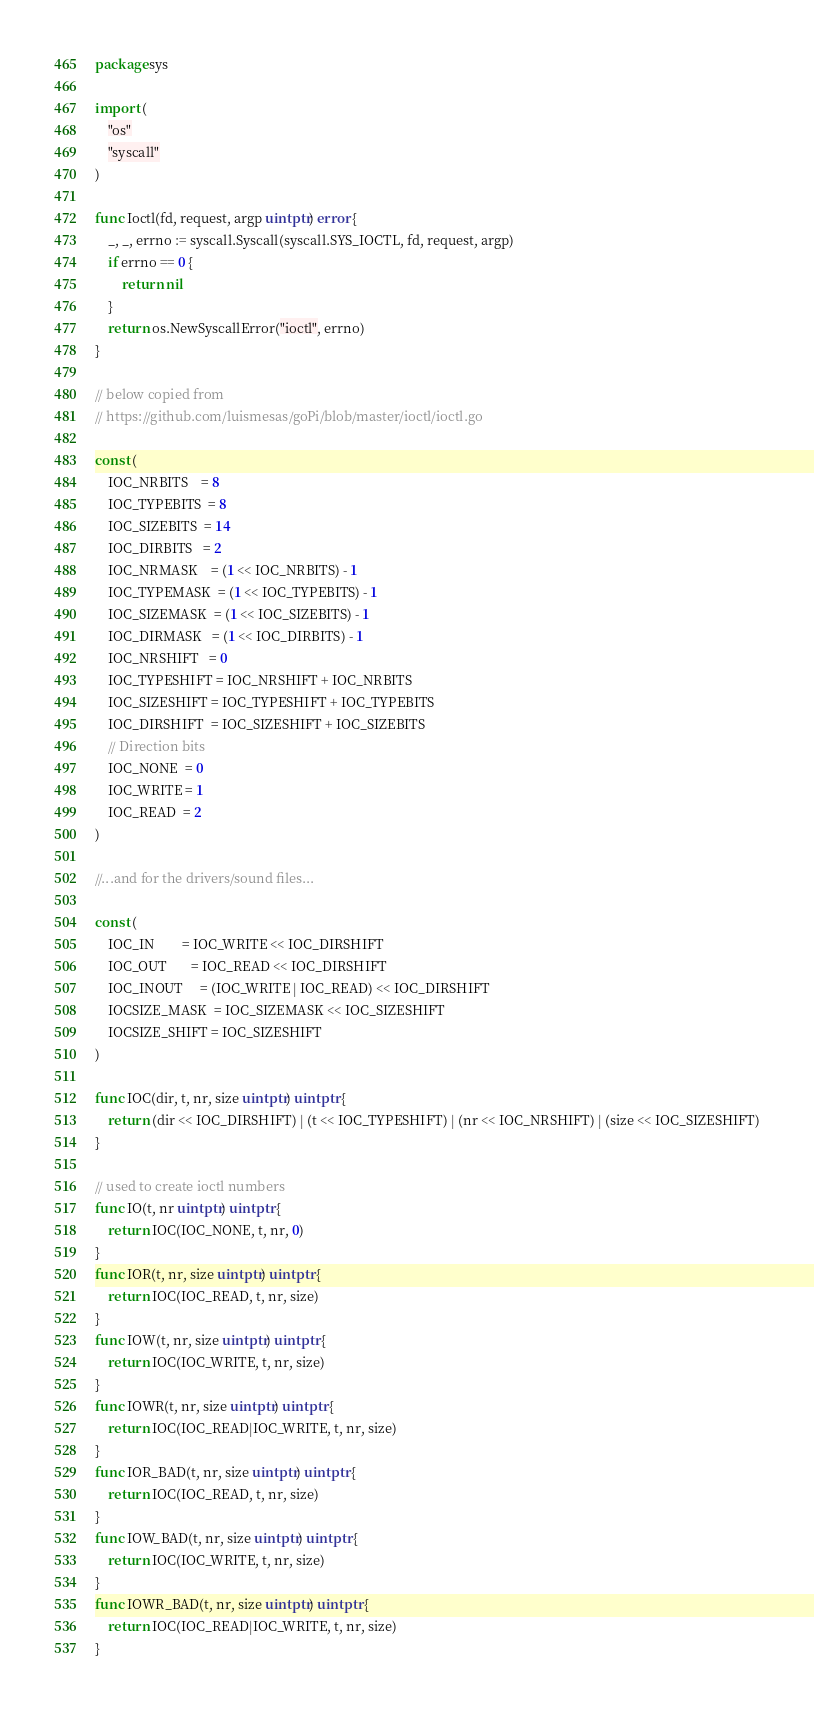<code> <loc_0><loc_0><loc_500><loc_500><_Go_>package sys

import (
	"os"
	"syscall"
)

func Ioctl(fd, request, argp uintptr) error {
	_, _, errno := syscall.Syscall(syscall.SYS_IOCTL, fd, request, argp)
	if errno == 0 {
		return nil
	}
	return os.NewSyscallError("ioctl", errno)
}

// below copied from
// https://github.com/luismesas/goPi/blob/master/ioctl/ioctl.go

const (
	IOC_NRBITS    = 8
	IOC_TYPEBITS  = 8
	IOC_SIZEBITS  = 14
	IOC_DIRBITS   = 2
	IOC_NRMASK    = (1 << IOC_NRBITS) - 1
	IOC_TYPEMASK  = (1 << IOC_TYPEBITS) - 1
	IOC_SIZEMASK  = (1 << IOC_SIZEBITS) - 1
	IOC_DIRMASK   = (1 << IOC_DIRBITS) - 1
	IOC_NRSHIFT   = 0
	IOC_TYPESHIFT = IOC_NRSHIFT + IOC_NRBITS
	IOC_SIZESHIFT = IOC_TYPESHIFT + IOC_TYPEBITS
	IOC_DIRSHIFT  = IOC_SIZESHIFT + IOC_SIZEBITS
	// Direction bits
	IOC_NONE  = 0
	IOC_WRITE = 1
	IOC_READ  = 2
)

//...and for the drivers/sound files...

const (
	IOC_IN        = IOC_WRITE << IOC_DIRSHIFT
	IOC_OUT       = IOC_READ << IOC_DIRSHIFT
	IOC_INOUT     = (IOC_WRITE | IOC_READ) << IOC_DIRSHIFT
	IOCSIZE_MASK  = IOC_SIZEMASK << IOC_SIZESHIFT
	IOCSIZE_SHIFT = IOC_SIZESHIFT
)

func IOC(dir, t, nr, size uintptr) uintptr {
	return (dir << IOC_DIRSHIFT) | (t << IOC_TYPESHIFT) | (nr << IOC_NRSHIFT) | (size << IOC_SIZESHIFT)
}

// used to create ioctl numbers
func IO(t, nr uintptr) uintptr {
	return IOC(IOC_NONE, t, nr, 0)
}
func IOR(t, nr, size uintptr) uintptr {
	return IOC(IOC_READ, t, nr, size)
}
func IOW(t, nr, size uintptr) uintptr {
	return IOC(IOC_WRITE, t, nr, size)
}
func IOWR(t, nr, size uintptr) uintptr {
	return IOC(IOC_READ|IOC_WRITE, t, nr, size)
}
func IOR_BAD(t, nr, size uintptr) uintptr {
	return IOC(IOC_READ, t, nr, size)
}
func IOW_BAD(t, nr, size uintptr) uintptr {
	return IOC(IOC_WRITE, t, nr, size)
}
func IOWR_BAD(t, nr, size uintptr) uintptr {
	return IOC(IOC_READ|IOC_WRITE, t, nr, size)
}
</code> 